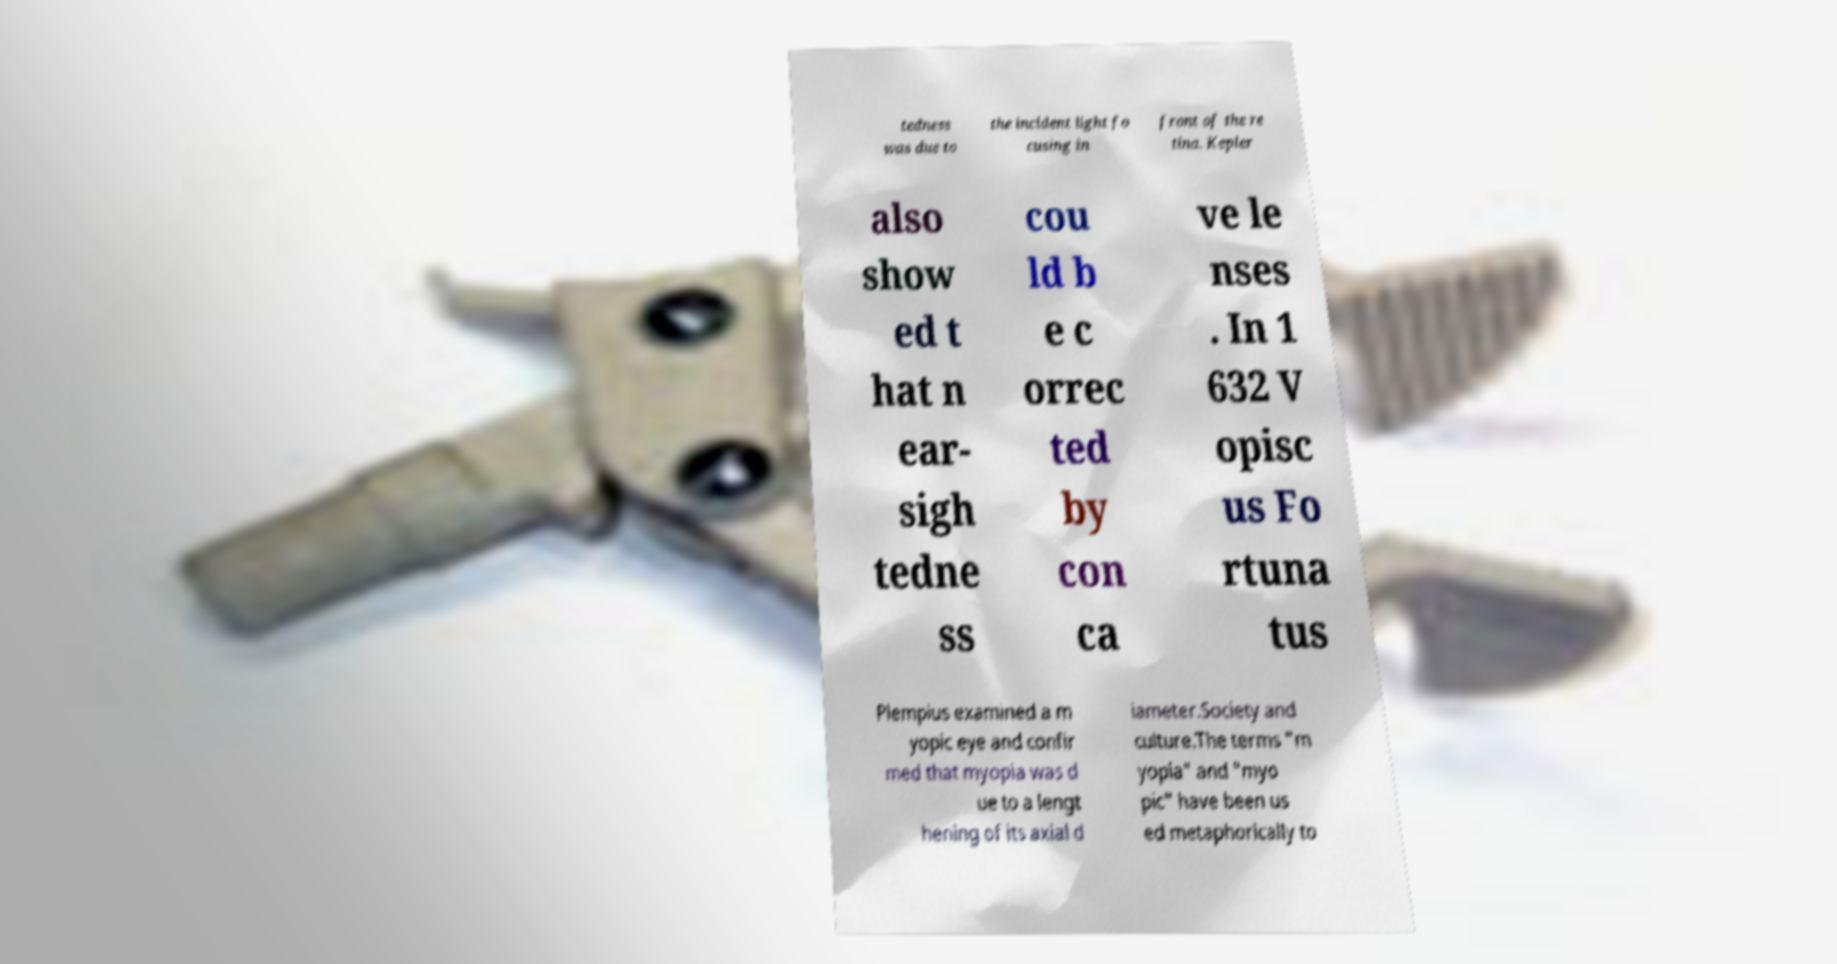Could you extract and type out the text from this image? tedness was due to the incident light fo cusing in front of the re tina. Kepler also show ed t hat n ear- sigh tedne ss cou ld b e c orrec ted by con ca ve le nses . In 1 632 V opisc us Fo rtuna tus Plempius examined a m yopic eye and confir med that myopia was d ue to a lengt hening of its axial d iameter.Society and culture.The terms "m yopia" and "myo pic" have been us ed metaphorically to 